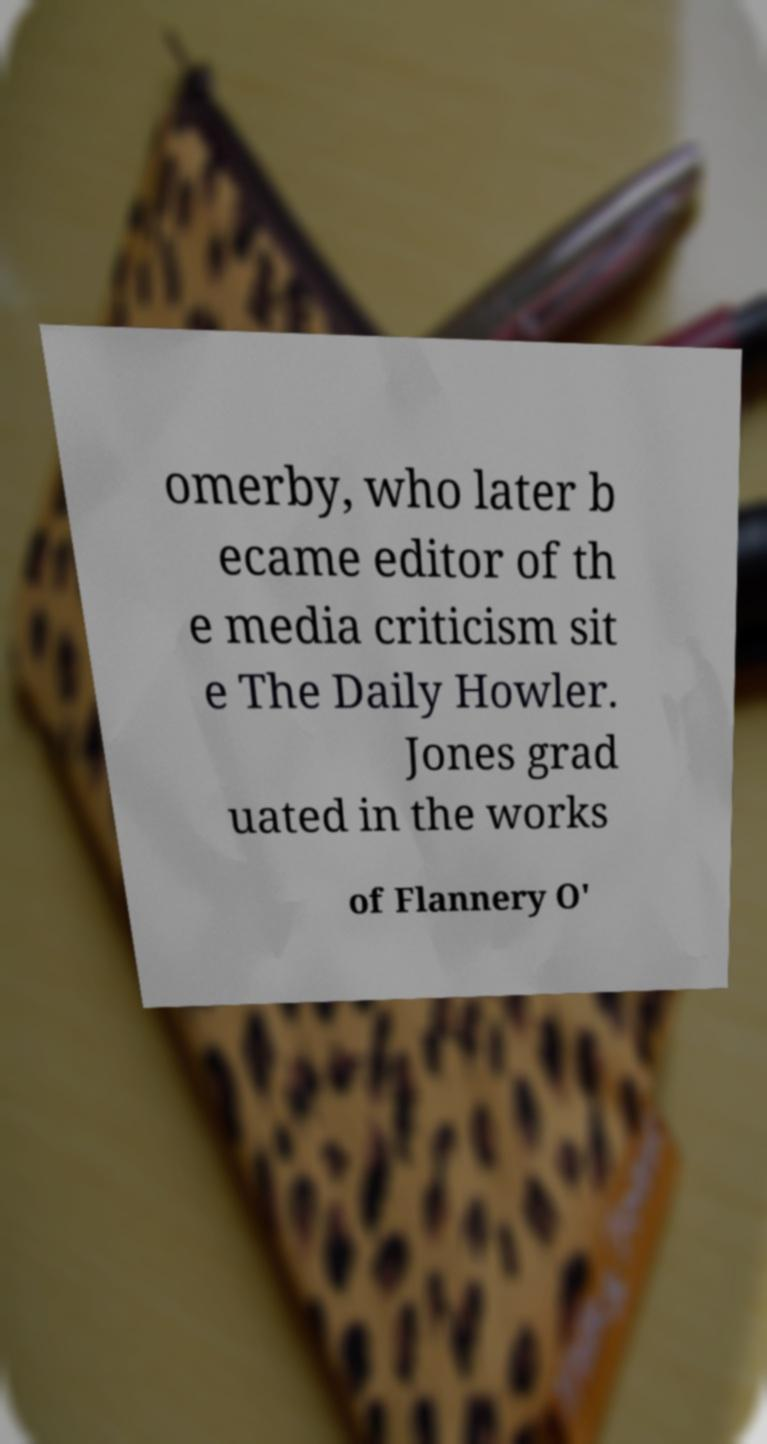What messages or text are displayed in this image? I need them in a readable, typed format. omerby, who later b ecame editor of th e media criticism sit e The Daily Howler. Jones grad uated in the works of Flannery O' 